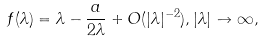Convert formula to latex. <formula><loc_0><loc_0><loc_500><loc_500>f ( \lambda ) = \lambda - \frac { a } { 2 \lambda } + O ( | \lambda | ^ { - 2 } ) , | \lambda | \to \infty ,</formula> 